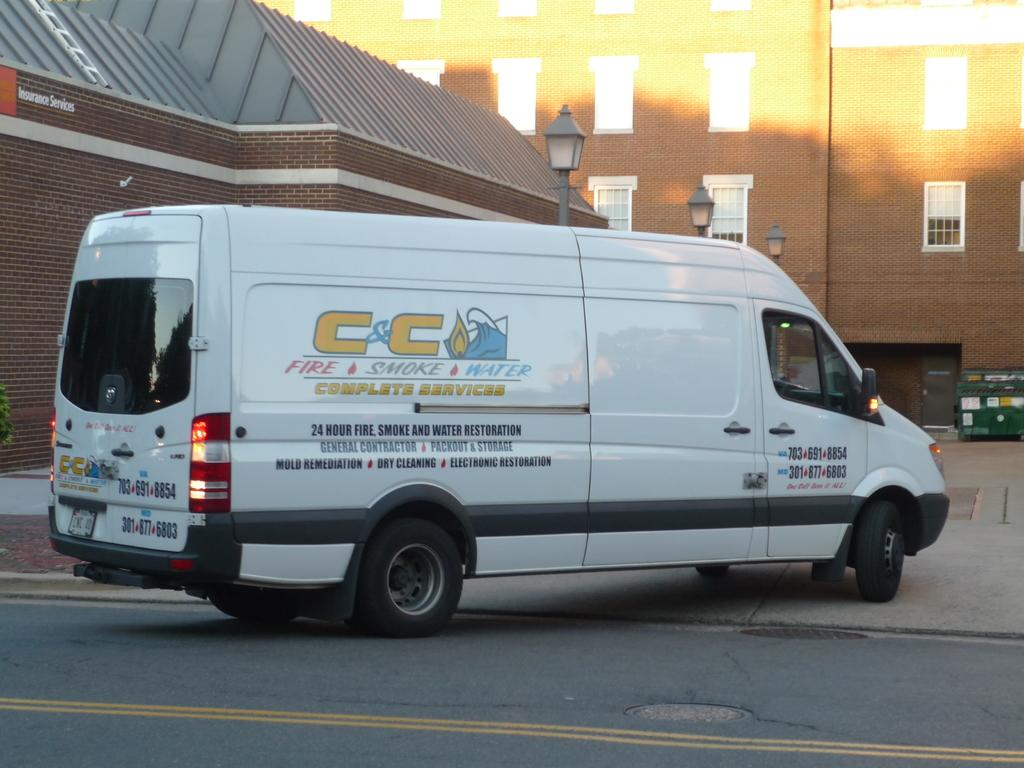<image>
Offer a succinct explanation of the picture presented. A van has company logo on the side and says it offers complete services. 